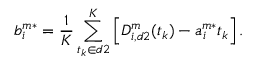<formula> <loc_0><loc_0><loc_500><loc_500>b _ { i } ^ { m * } = \frac { 1 } { K } \sum _ { t _ { k } \in d 2 } ^ { K } \left [ D _ { i , d 2 } ^ { m } ( t _ { k } ) - a _ { i } ^ { m * } t _ { k } \right ] .</formula> 